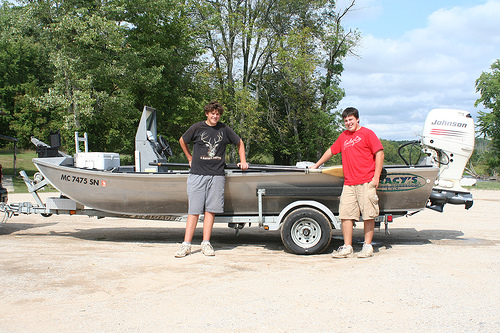<image>
Is there a boy next to the boat? Yes. The boy is positioned adjacent to the boat, located nearby in the same general area. 